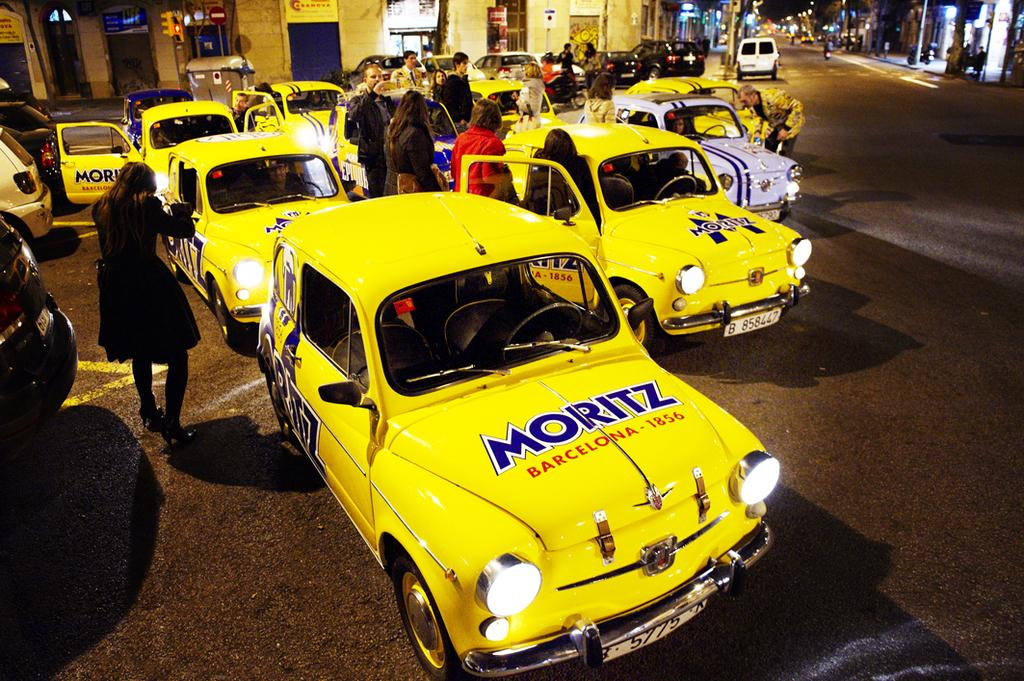<image>
Describe the image concisely. A fleet of bright yeallow classic cars are being looked at by people, the nearest bears the words Moritz and Barecelona 1856 on its bonnet 